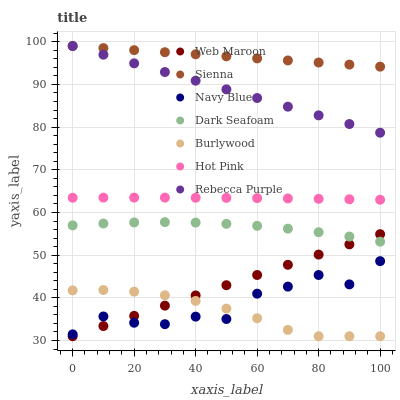Does Burlywood have the minimum area under the curve?
Answer yes or no. Yes. Does Sienna have the maximum area under the curve?
Answer yes or no. Yes. Does Navy Blue have the minimum area under the curve?
Answer yes or no. No. Does Navy Blue have the maximum area under the curve?
Answer yes or no. No. Is Sienna the smoothest?
Answer yes or no. Yes. Is Navy Blue the roughest?
Answer yes or no. Yes. Is Hot Pink the smoothest?
Answer yes or no. No. Is Hot Pink the roughest?
Answer yes or no. No. Does Burlywood have the lowest value?
Answer yes or no. Yes. Does Navy Blue have the lowest value?
Answer yes or no. No. Does Rebecca Purple have the highest value?
Answer yes or no. Yes. Does Navy Blue have the highest value?
Answer yes or no. No. Is Navy Blue less than Dark Seafoam?
Answer yes or no. Yes. Is Sienna greater than Hot Pink?
Answer yes or no. Yes. Does Burlywood intersect Web Maroon?
Answer yes or no. Yes. Is Burlywood less than Web Maroon?
Answer yes or no. No. Is Burlywood greater than Web Maroon?
Answer yes or no. No. Does Navy Blue intersect Dark Seafoam?
Answer yes or no. No. 